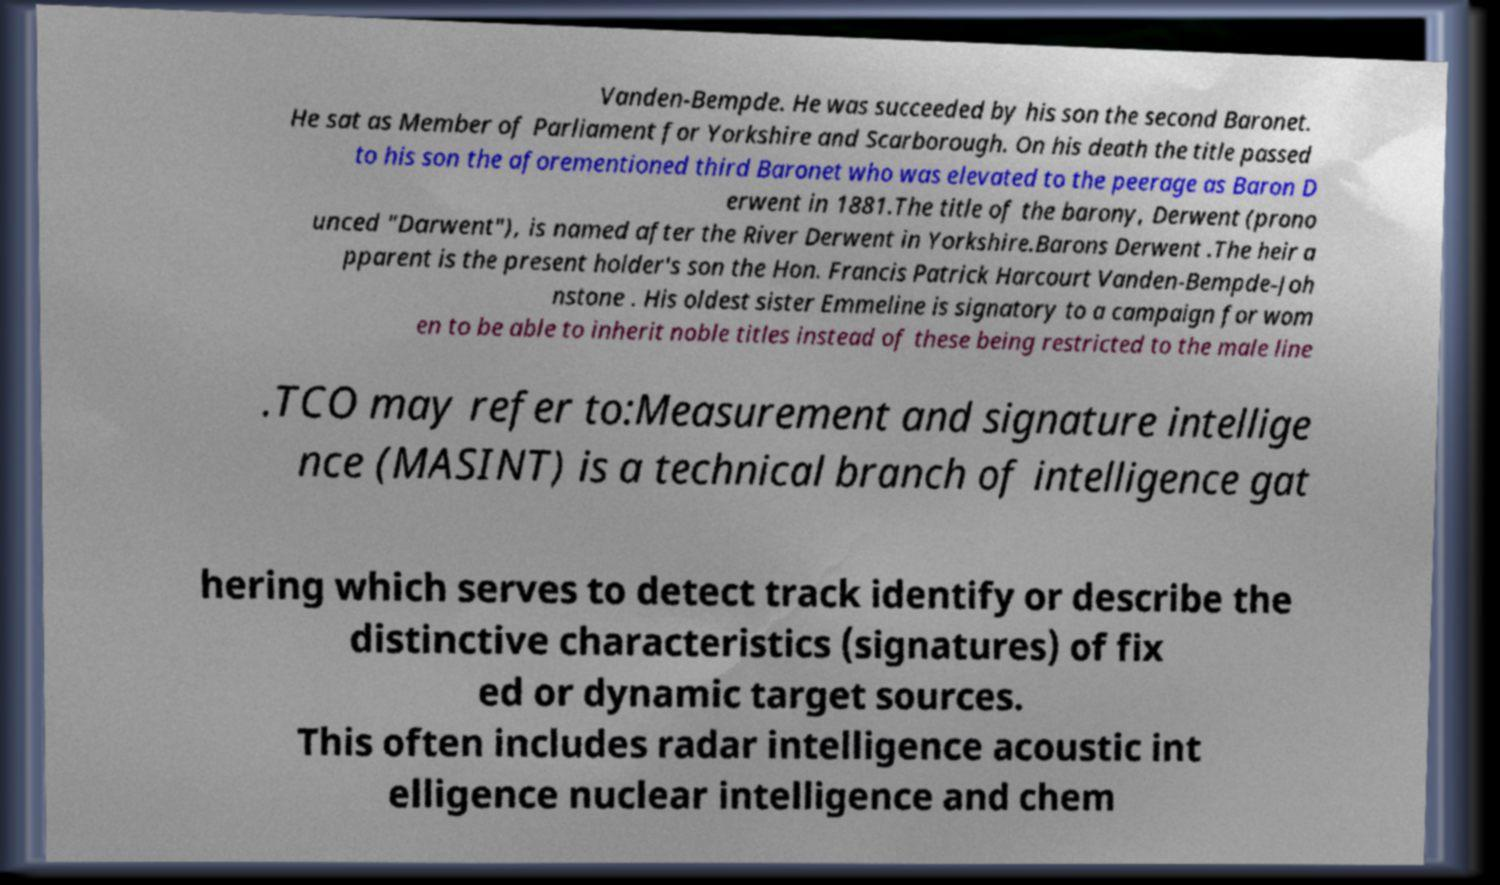Can you read and provide the text displayed in the image?This photo seems to have some interesting text. Can you extract and type it out for me? Vanden-Bempde. He was succeeded by his son the second Baronet. He sat as Member of Parliament for Yorkshire and Scarborough. On his death the title passed to his son the aforementioned third Baronet who was elevated to the peerage as Baron D erwent in 1881.The title of the barony, Derwent (prono unced "Darwent"), is named after the River Derwent in Yorkshire.Barons Derwent .The heir a pparent is the present holder's son the Hon. Francis Patrick Harcourt Vanden-Bempde-Joh nstone . His oldest sister Emmeline is signatory to a campaign for wom en to be able to inherit noble titles instead of these being restricted to the male line .TCO may refer to:Measurement and signature intellige nce (MASINT) is a technical branch of intelligence gat hering which serves to detect track identify or describe the distinctive characteristics (signatures) of fix ed or dynamic target sources. This often includes radar intelligence acoustic int elligence nuclear intelligence and chem 